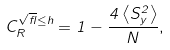<formula> <loc_0><loc_0><loc_500><loc_500>C _ { R } ^ { \sqrt { \gamma } \leq h } = 1 - \frac { 4 \left \langle S _ { y } ^ { 2 } \right \rangle } { N } ,</formula> 